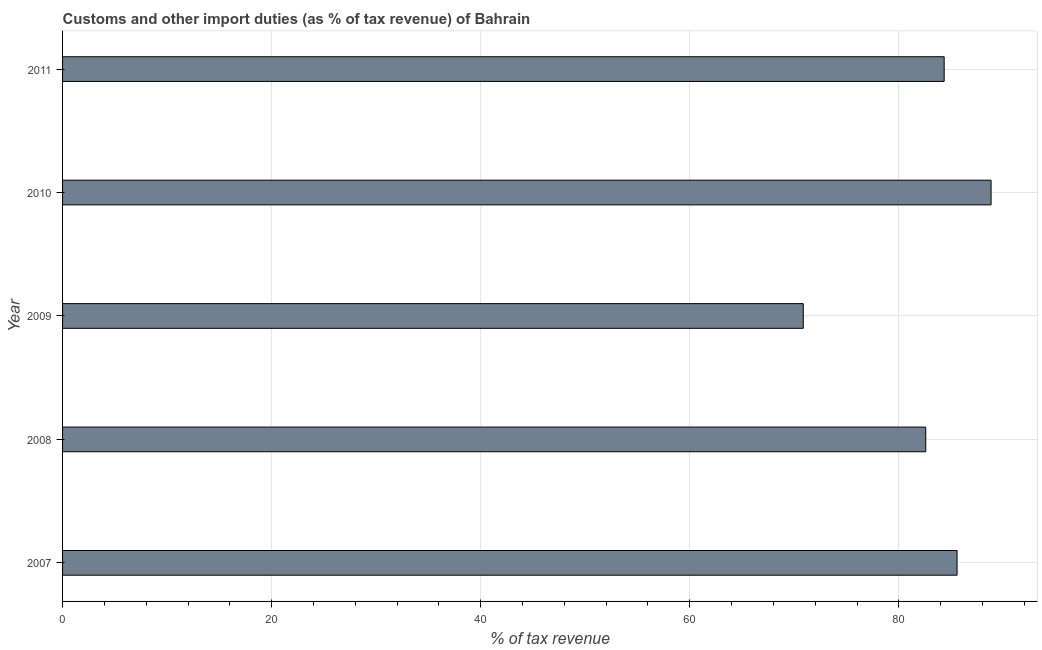Does the graph contain any zero values?
Give a very brief answer. No. What is the title of the graph?
Provide a succinct answer. Customs and other import duties (as % of tax revenue) of Bahrain. What is the label or title of the X-axis?
Give a very brief answer. % of tax revenue. What is the label or title of the Y-axis?
Offer a very short reply. Year. What is the customs and other import duties in 2008?
Provide a succinct answer. 82.57. Across all years, what is the maximum customs and other import duties?
Give a very brief answer. 88.82. Across all years, what is the minimum customs and other import duties?
Ensure brevity in your answer.  70.86. In which year was the customs and other import duties maximum?
Keep it short and to the point. 2010. In which year was the customs and other import duties minimum?
Your response must be concise. 2009. What is the sum of the customs and other import duties?
Give a very brief answer. 412.16. What is the difference between the customs and other import duties in 2008 and 2010?
Your response must be concise. -6.25. What is the average customs and other import duties per year?
Keep it short and to the point. 82.43. What is the median customs and other import duties?
Keep it short and to the point. 84.34. In how many years, is the customs and other import duties greater than 20 %?
Ensure brevity in your answer.  5. Do a majority of the years between 2011 and 2007 (inclusive) have customs and other import duties greater than 36 %?
Your answer should be compact. Yes. What is the ratio of the customs and other import duties in 2007 to that in 2008?
Provide a short and direct response. 1.04. Is the difference between the customs and other import duties in 2007 and 2011 greater than the difference between any two years?
Your answer should be compact. No. What is the difference between the highest and the second highest customs and other import duties?
Your answer should be very brief. 3.25. What is the difference between the highest and the lowest customs and other import duties?
Your answer should be very brief. 17.96. How many bars are there?
Offer a very short reply. 5. Are all the bars in the graph horizontal?
Offer a very short reply. Yes. How many years are there in the graph?
Ensure brevity in your answer.  5. Are the values on the major ticks of X-axis written in scientific E-notation?
Give a very brief answer. No. What is the % of tax revenue of 2007?
Ensure brevity in your answer.  85.57. What is the % of tax revenue of 2008?
Offer a very short reply. 82.57. What is the % of tax revenue of 2009?
Give a very brief answer. 70.86. What is the % of tax revenue of 2010?
Your response must be concise. 88.82. What is the % of tax revenue in 2011?
Your answer should be compact. 84.34. What is the difference between the % of tax revenue in 2007 and 2008?
Your response must be concise. 3. What is the difference between the % of tax revenue in 2007 and 2009?
Offer a terse response. 14.71. What is the difference between the % of tax revenue in 2007 and 2010?
Give a very brief answer. -3.25. What is the difference between the % of tax revenue in 2007 and 2011?
Keep it short and to the point. 1.23. What is the difference between the % of tax revenue in 2008 and 2009?
Keep it short and to the point. 11.71. What is the difference between the % of tax revenue in 2008 and 2010?
Offer a very short reply. -6.25. What is the difference between the % of tax revenue in 2008 and 2011?
Offer a very short reply. -1.76. What is the difference between the % of tax revenue in 2009 and 2010?
Ensure brevity in your answer.  -17.96. What is the difference between the % of tax revenue in 2009 and 2011?
Your answer should be very brief. -13.48. What is the difference between the % of tax revenue in 2010 and 2011?
Your response must be concise. 4.49. What is the ratio of the % of tax revenue in 2007 to that in 2008?
Offer a terse response. 1.04. What is the ratio of the % of tax revenue in 2007 to that in 2009?
Keep it short and to the point. 1.21. What is the ratio of the % of tax revenue in 2007 to that in 2010?
Your answer should be compact. 0.96. What is the ratio of the % of tax revenue in 2008 to that in 2009?
Make the answer very short. 1.17. What is the ratio of the % of tax revenue in 2009 to that in 2010?
Keep it short and to the point. 0.8. What is the ratio of the % of tax revenue in 2009 to that in 2011?
Your answer should be very brief. 0.84. What is the ratio of the % of tax revenue in 2010 to that in 2011?
Give a very brief answer. 1.05. 